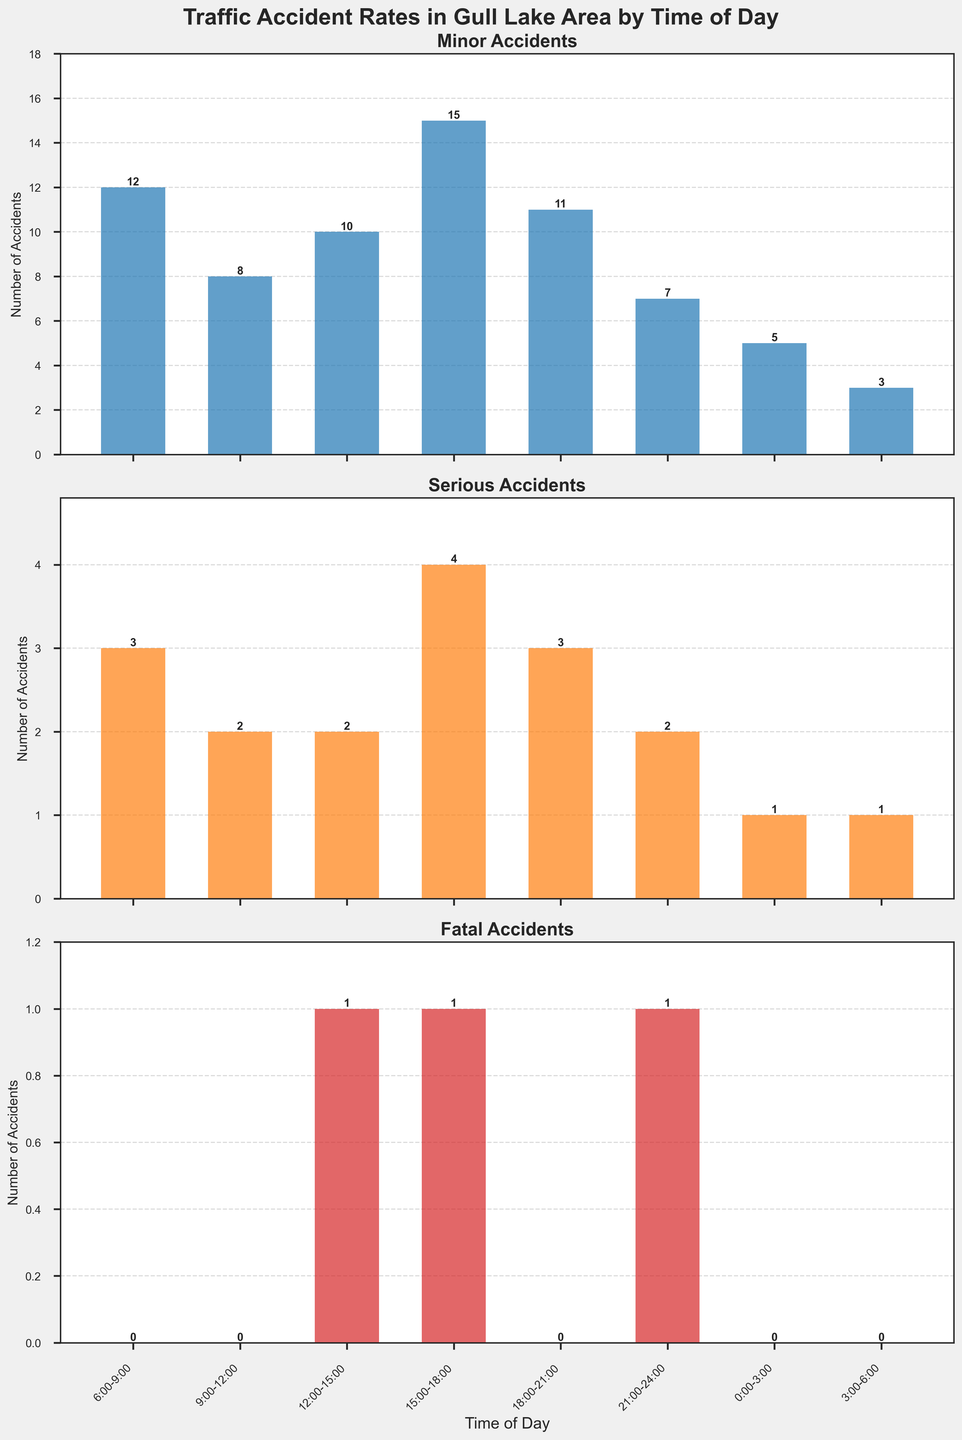what is the title of the figure? The title of the figure is located at the top and provides an overview of what the figure represents. Reading it directly from the figure, it is "Traffic Accident Rates in Gull Lake Area by Time of Day"
Answer: Traffic Accident Rates in Gull Lake Area by Time of Day During which time period do minor accidents peak? To find when minor accidents peak, look at the bar heights in the minor accidents subplot and find the tallest bar.
Answer: 15:00-18:00 How many serious accidents occur between 6:00-9:00 and between 21:00-24:00? Add the number of serious accidents for these time periods: for 6:00-9:00, it's 3, and for 21:00-24:00, it's 2. Adding these gives 3 + 2 = 5
Answer: 5 Which time period has the least number of minor accidents, and what is that number? The least number of minor accidents occurs at 3:00-6:00 as indicated by the bar's height. The number is 3.
Answer: 3:00-6:00, 3 Are there any periods with no fatal accidents? Look at the fatal accidents subplot and check for time periods where the bars have a height of 0.
Answer: Yes, 6:00-9:00, 9:00-12:00, 18:00-21:00, 0:00-3:00, 3:00-6:00 How many total accidents occur in the 15:00-18:00 period across all categories? Add the accidents in this period: 15 minor, 4 serious, 1 fatal. The total is 15 + 4 + 1 = 20
Answer: 20 During which time period(s) do we see both serious and fatal accidents? Check both serious and fatal accidents subplots, and look for periods where both have non-zero values.
Answer: 12:00-15:00, 15:00-18:00, 21:00-24:00 What is the average number of minor accidents throughout the day? Add the number of minor accidents across all time periods and divide by the number of periods: (12 + 8 + 10 + 15 + 11 + 7 + 5 + 3) / 8 = 71 / 8 = 8.875
Answer: 8.875 Do more serious accidents occur in the morning (6:00-12:00) or in the evening (18:00-24:00)? Sum serious accidents in the morning (6:00-9:00 and 9:00-12:00) which gives 3 + 2 = 5, and in the evening (18:00-21:00 and 21:00-24:00) which gives 3 + 2 = 5. Compare these sums.
Answer: Equal, both have 5 How many fatal accidents are there in total? Add the number of fatal accidents throughout all periods: (0 + 0 + 1 + 1 + 0 + 1 + 0 + 0) = 3
Answer: 3 